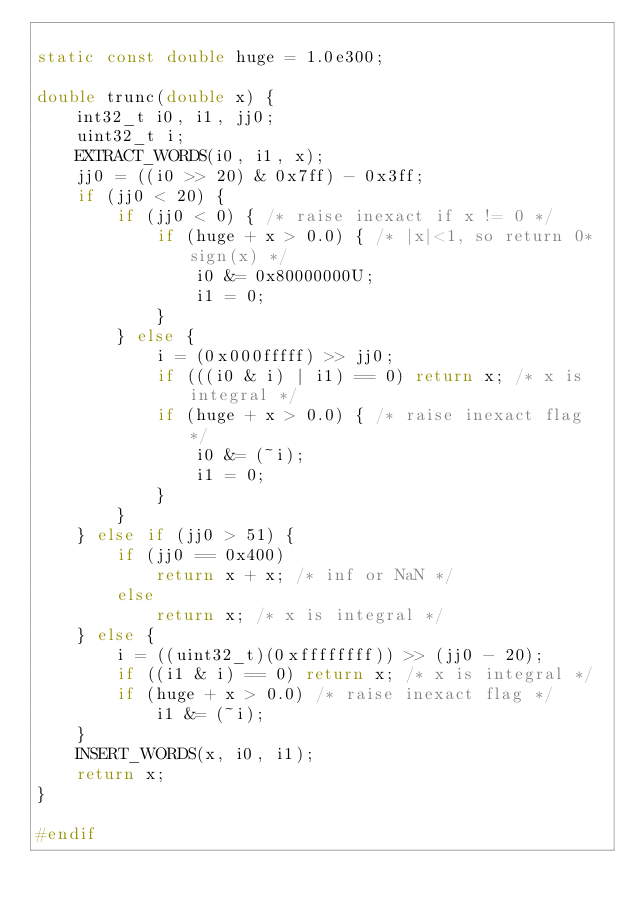Convert code to text. <code><loc_0><loc_0><loc_500><loc_500><_C_>
static const double huge = 1.0e300;

double trunc(double x) {
    int32_t i0, i1, jj0;
    uint32_t i;
    EXTRACT_WORDS(i0, i1, x);
    jj0 = ((i0 >> 20) & 0x7ff) - 0x3ff;
    if (jj0 < 20) {
        if (jj0 < 0) { /* raise inexact if x != 0 */
            if (huge + x > 0.0) { /* |x|<1, so return 0*sign(x) */
                i0 &= 0x80000000U;
                i1 = 0;
            }
        } else {
            i = (0x000fffff) >> jj0;
            if (((i0 & i) | i1) == 0) return x; /* x is integral */
            if (huge + x > 0.0) { /* raise inexact flag */
                i0 &= (~i);
                i1 = 0;
            }
        }
    } else if (jj0 > 51) {
        if (jj0 == 0x400)
            return x + x; /* inf or NaN */
        else
            return x; /* x is integral */
    } else {
        i = ((uint32_t)(0xffffffff)) >> (jj0 - 20);
        if ((i1 & i) == 0) return x; /* x is integral */
        if (huge + x > 0.0) /* raise inexact flag */
            i1 &= (~i);
    }
    INSERT_WORDS(x, i0, i1);
    return x;
}

#endif
</code> 